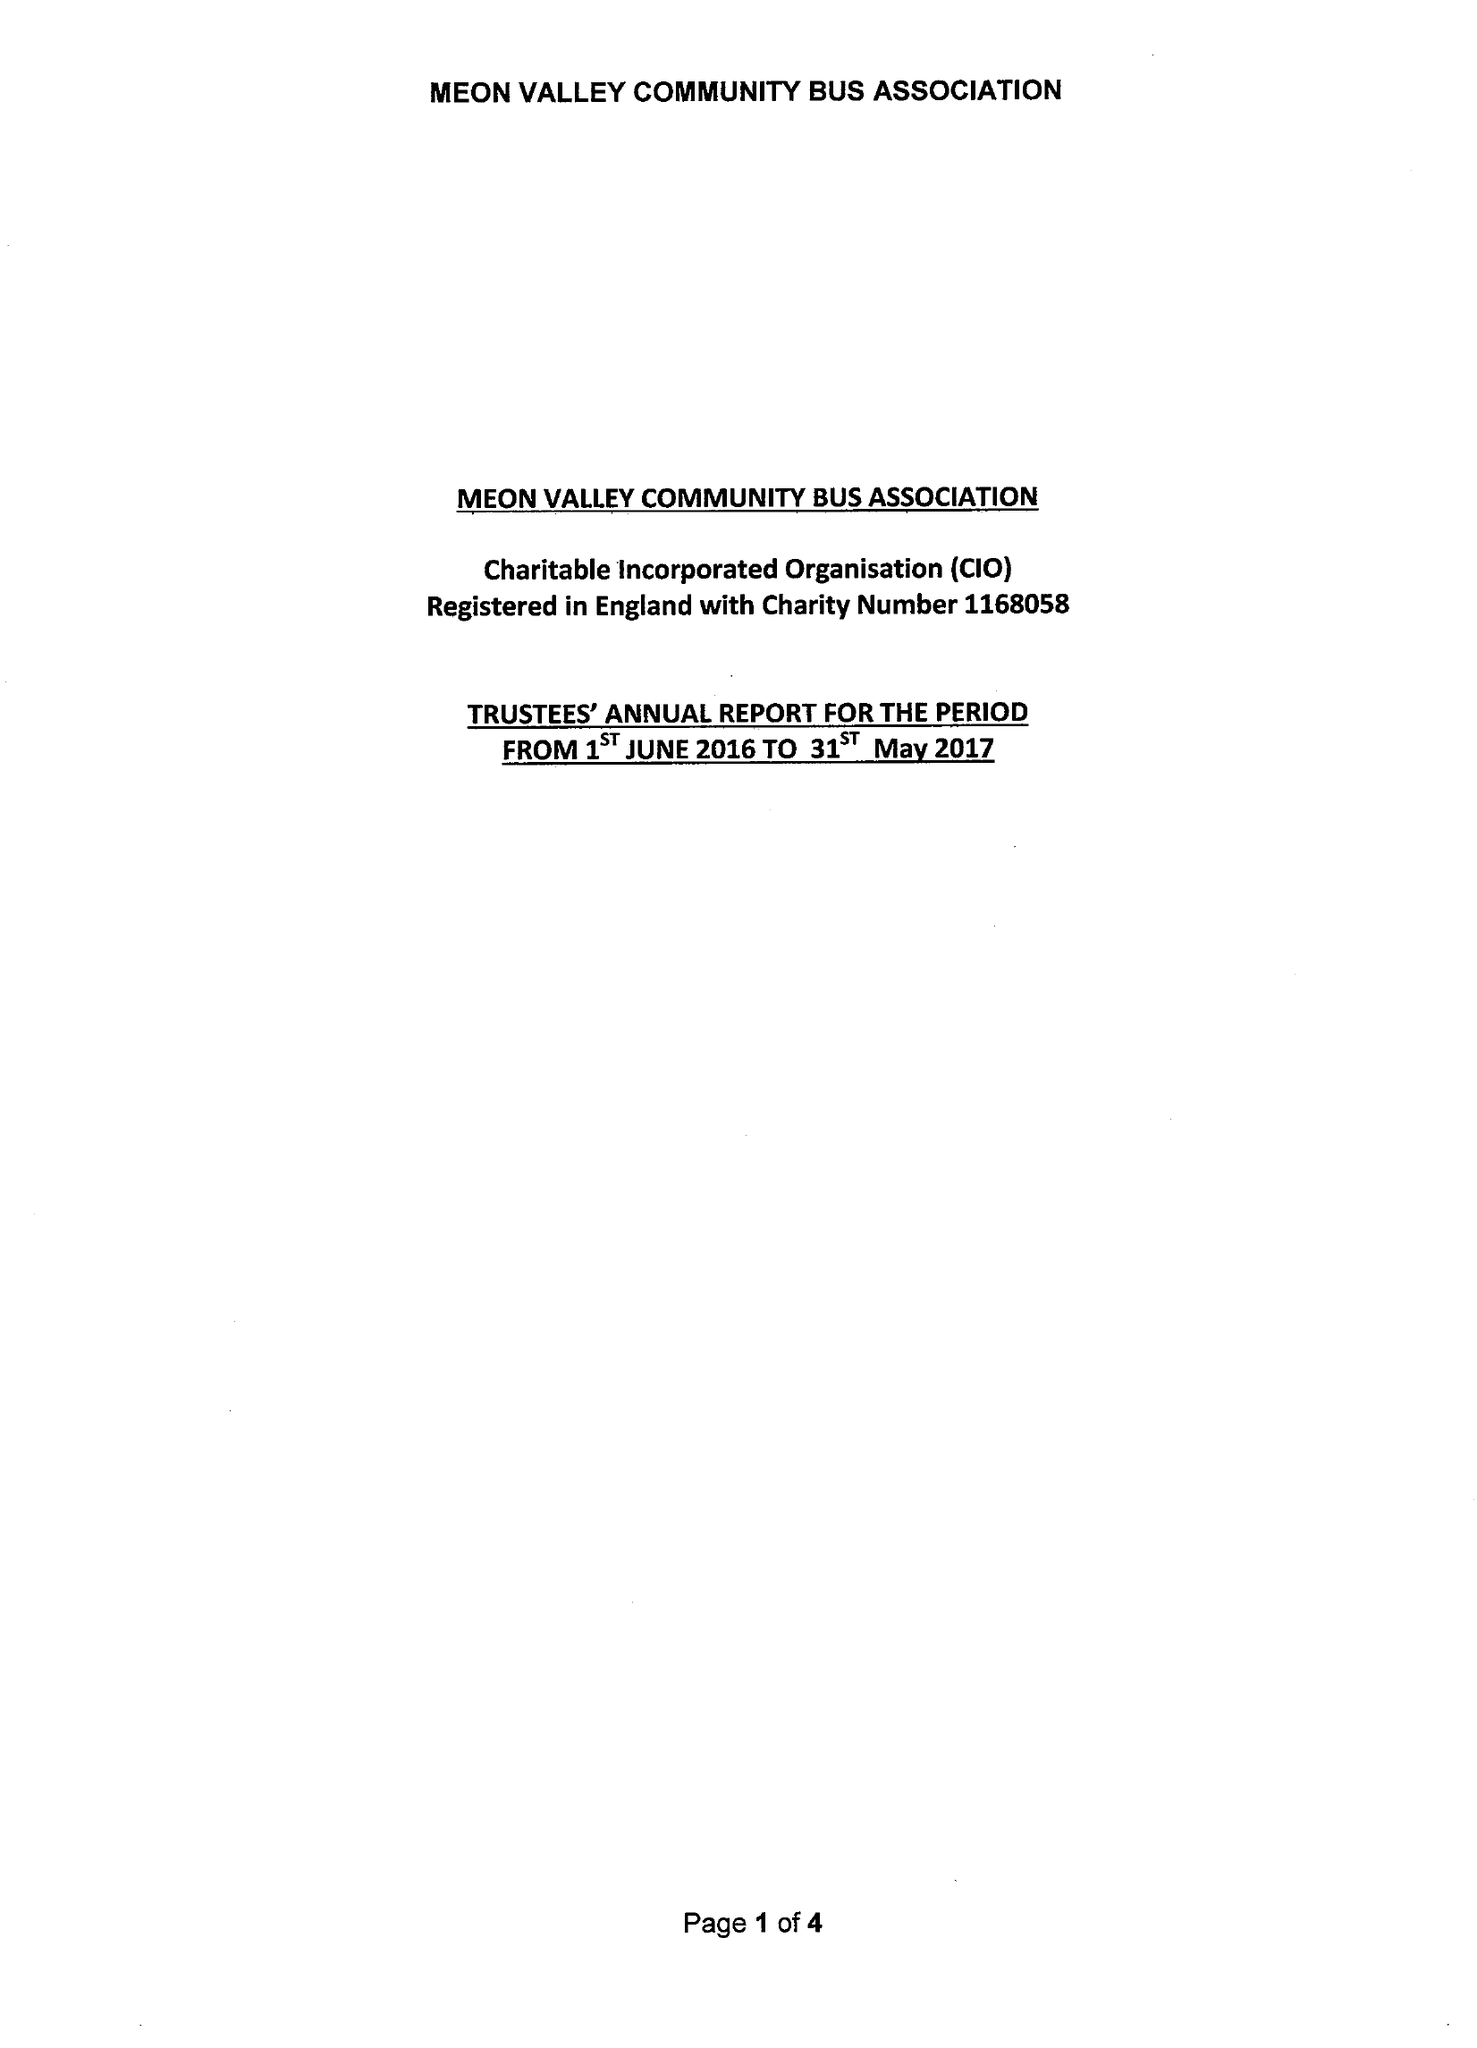What is the value for the address__postcode?
Answer the question using a single word or phrase. SO32 3QU 